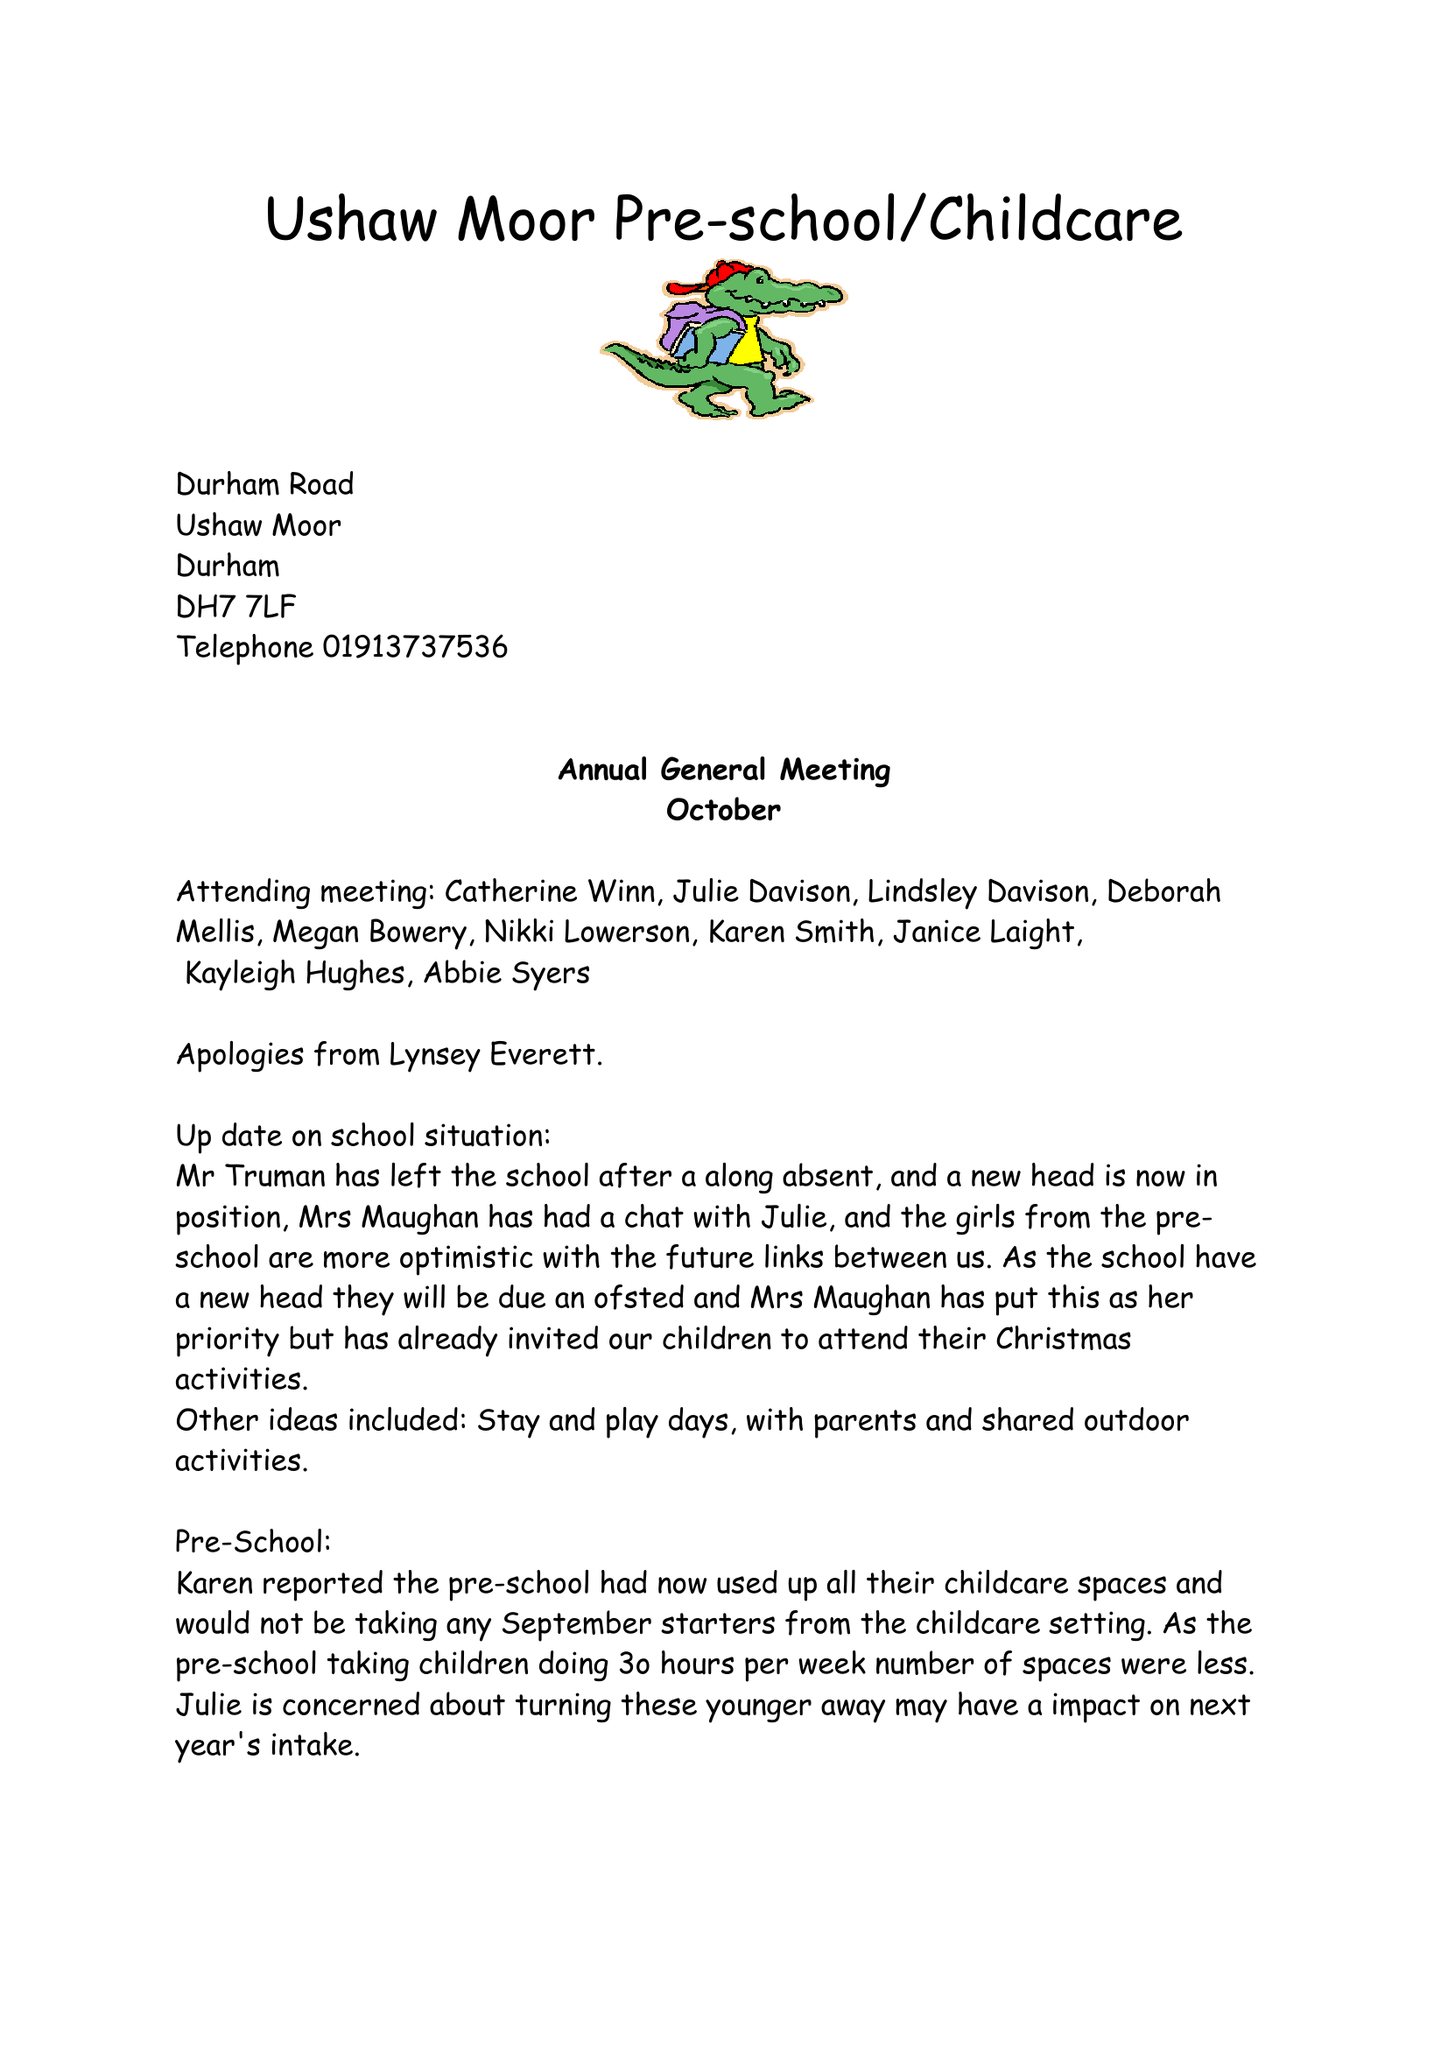What is the value for the income_annually_in_british_pounds?
Answer the question using a single word or phrase. 199658.00 